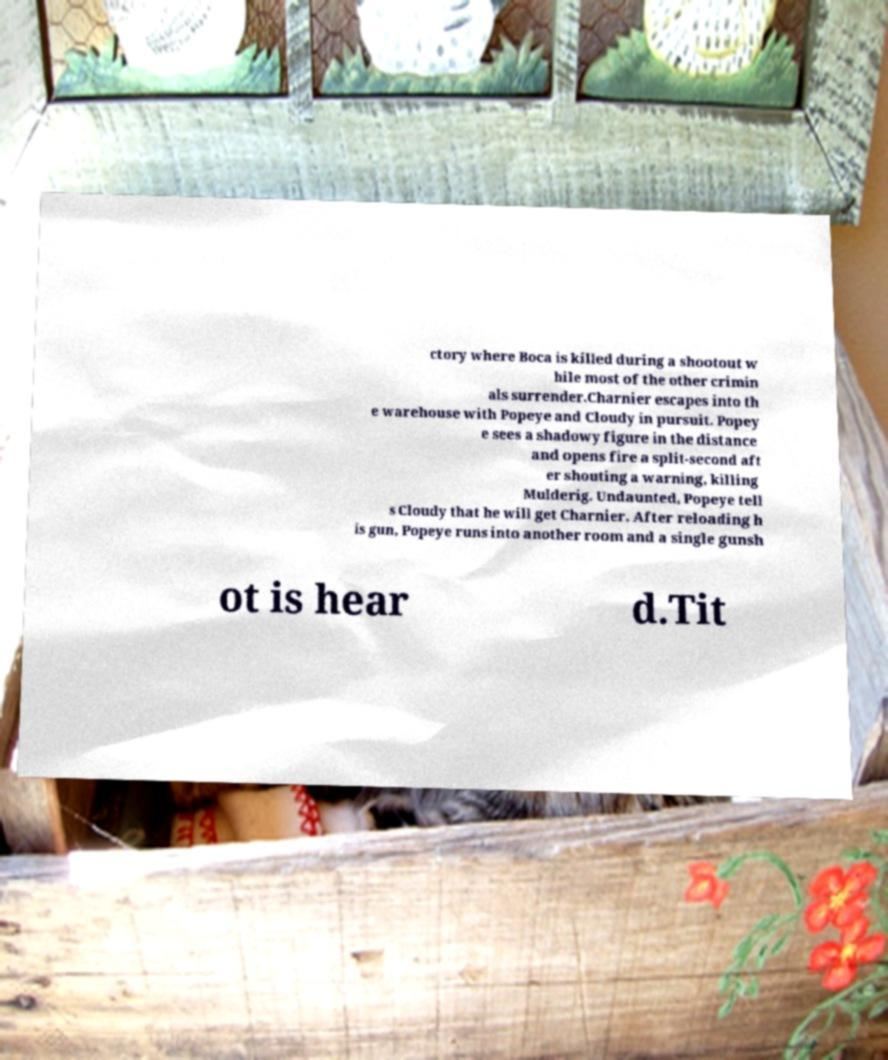Could you extract and type out the text from this image? ctory where Boca is killed during a shootout w hile most of the other crimin als surrender.Charnier escapes into th e warehouse with Popeye and Cloudy in pursuit. Popey e sees a shadowy figure in the distance and opens fire a split-second aft er shouting a warning, killing Mulderig. Undaunted, Popeye tell s Cloudy that he will get Charnier. After reloading h is gun, Popeye runs into another room and a single gunsh ot is hear d.Tit 